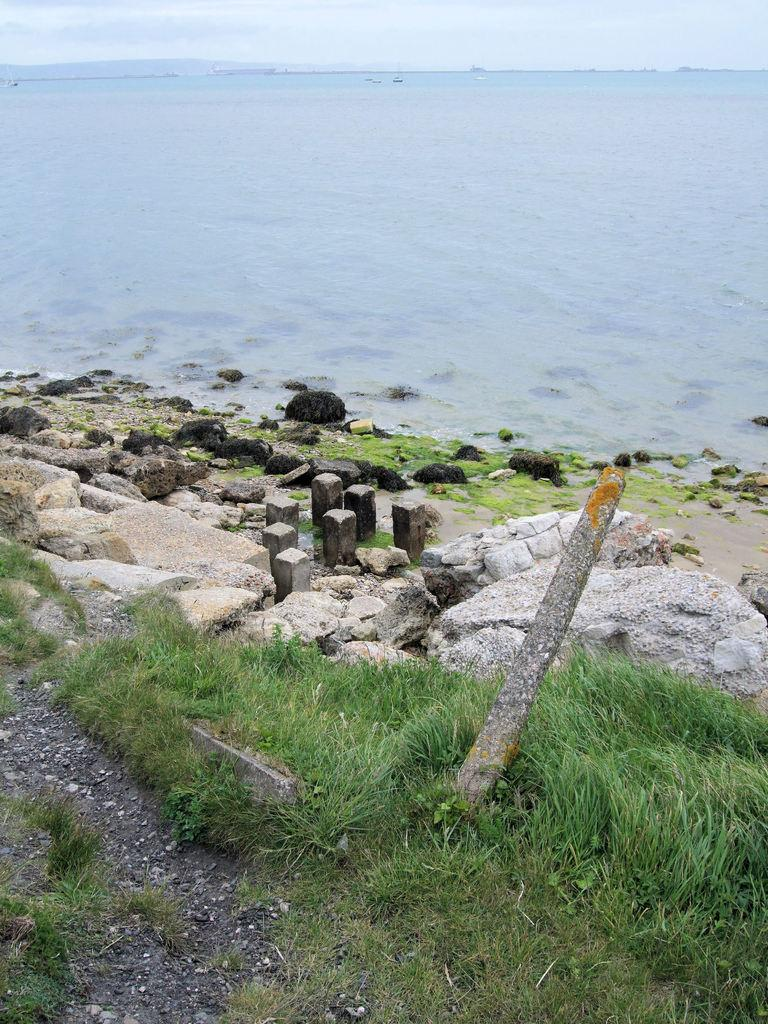What type of terrain is visible on the land in the image? There are rocks and grass on the land in the image. What can be seen on the water in the image? There are boats sailing on the water in the image. What is located on the left side of the image? There is a hill on the left side of the image. What is visible at the top of the image? The sky is visible at the top of the image. How does the plane take off from the hill in the image? There is no plane present in the image; it only features rocks, grass, boats, a hill, and the sky. What type of cast is visible on the rocks in the image? There is no cast present on the rocks in the image. 